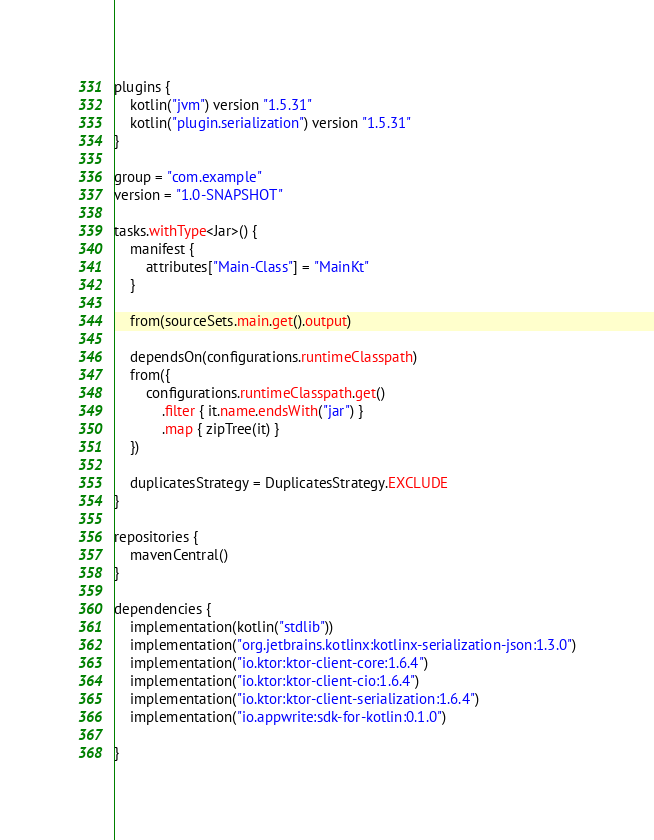<code> <loc_0><loc_0><loc_500><loc_500><_Kotlin_>plugins {
    kotlin("jvm") version "1.5.31"
    kotlin("plugin.serialization") version "1.5.31"
}

group = "com.example"
version = "1.0-SNAPSHOT"

tasks.withType<Jar>() {
    manifest {
        attributes["Main-Class"] = "MainKt"
    }

    from(sourceSets.main.get().output)

    dependsOn(configurations.runtimeClasspath)
    from({
        configurations.runtimeClasspath.get()
            .filter { it.name.endsWith("jar") }
            .map { zipTree(it) }
    })

    duplicatesStrategy = DuplicatesStrategy.EXCLUDE
}

repositories {
    mavenCentral()
}

dependencies {
    implementation(kotlin("stdlib"))
    implementation("org.jetbrains.kotlinx:kotlinx-serialization-json:1.3.0")
    implementation("io.ktor:ktor-client-core:1.6.4")
    implementation("io.ktor:ktor-client-cio:1.6.4")
    implementation("io.ktor:ktor-client-serialization:1.6.4")
    implementation("io.appwrite:sdk-for-kotlin:0.1.0")

}
</code> 